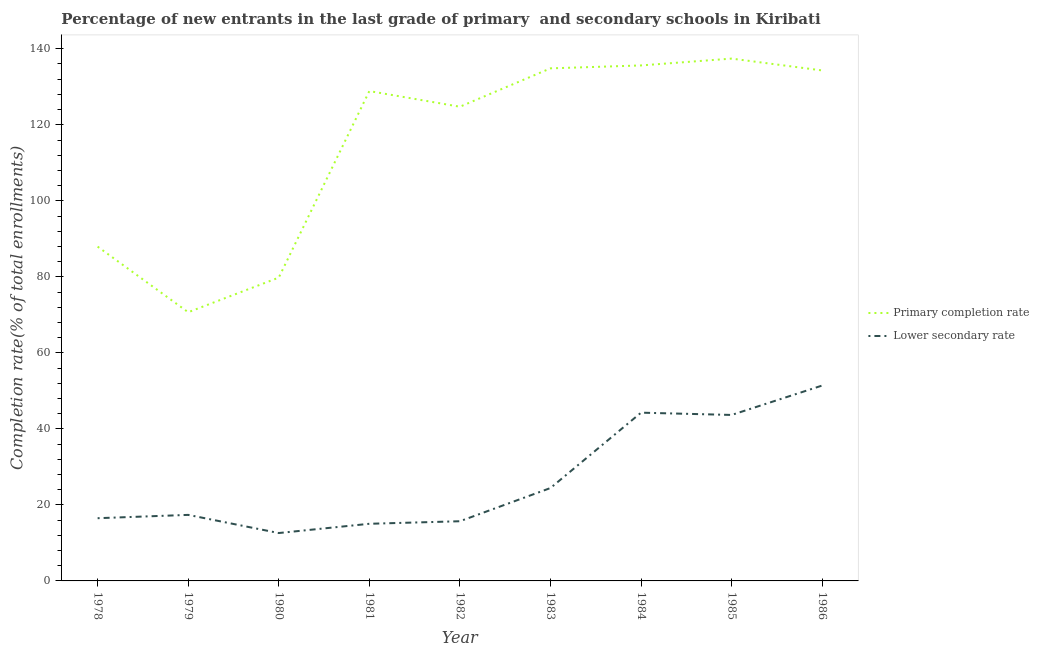How many different coloured lines are there?
Your answer should be very brief. 2. What is the completion rate in primary schools in 1983?
Ensure brevity in your answer.  134.85. Across all years, what is the maximum completion rate in primary schools?
Provide a short and direct response. 137.42. Across all years, what is the minimum completion rate in primary schools?
Your answer should be very brief. 70.69. In which year was the completion rate in primary schools minimum?
Ensure brevity in your answer.  1979. What is the total completion rate in primary schools in the graph?
Offer a terse response. 1034.25. What is the difference between the completion rate in secondary schools in 1978 and that in 1985?
Your answer should be compact. -27.17. What is the difference between the completion rate in secondary schools in 1980 and the completion rate in primary schools in 1985?
Make the answer very short. -124.82. What is the average completion rate in primary schools per year?
Keep it short and to the point. 114.92. In the year 1986, what is the difference between the completion rate in primary schools and completion rate in secondary schools?
Provide a short and direct response. 82.9. What is the ratio of the completion rate in secondary schools in 1979 to that in 1985?
Keep it short and to the point. 0.4. Is the difference between the completion rate in secondary schools in 1981 and 1984 greater than the difference between the completion rate in primary schools in 1981 and 1984?
Your response must be concise. No. What is the difference between the highest and the second highest completion rate in primary schools?
Keep it short and to the point. 1.8. What is the difference between the highest and the lowest completion rate in secondary schools?
Ensure brevity in your answer.  38.8. In how many years, is the completion rate in primary schools greater than the average completion rate in primary schools taken over all years?
Your response must be concise. 6. Is the sum of the completion rate in primary schools in 1978 and 1986 greater than the maximum completion rate in secondary schools across all years?
Your answer should be very brief. Yes. Is the completion rate in primary schools strictly less than the completion rate in secondary schools over the years?
Offer a very short reply. No. How many lines are there?
Give a very brief answer. 2. How many years are there in the graph?
Make the answer very short. 9. Does the graph contain any zero values?
Your response must be concise. No. What is the title of the graph?
Keep it short and to the point. Percentage of new entrants in the last grade of primary  and secondary schools in Kiribati. Does "Largest city" appear as one of the legend labels in the graph?
Keep it short and to the point. No. What is the label or title of the Y-axis?
Your answer should be very brief. Completion rate(% of total enrollments). What is the Completion rate(% of total enrollments) of Primary completion rate in 1978?
Ensure brevity in your answer.  87.95. What is the Completion rate(% of total enrollments) of Lower secondary rate in 1978?
Provide a succinct answer. 16.5. What is the Completion rate(% of total enrollments) of Primary completion rate in 1979?
Offer a very short reply. 70.69. What is the Completion rate(% of total enrollments) of Lower secondary rate in 1979?
Keep it short and to the point. 17.37. What is the Completion rate(% of total enrollments) of Primary completion rate in 1980?
Give a very brief answer. 79.8. What is the Completion rate(% of total enrollments) of Lower secondary rate in 1980?
Your answer should be very brief. 12.6. What is the Completion rate(% of total enrollments) in Primary completion rate in 1981?
Your answer should be very brief. 128.87. What is the Completion rate(% of total enrollments) of Lower secondary rate in 1981?
Give a very brief answer. 15.03. What is the Completion rate(% of total enrollments) in Primary completion rate in 1982?
Provide a succinct answer. 124.75. What is the Completion rate(% of total enrollments) in Lower secondary rate in 1982?
Make the answer very short. 15.7. What is the Completion rate(% of total enrollments) in Primary completion rate in 1983?
Offer a terse response. 134.85. What is the Completion rate(% of total enrollments) of Lower secondary rate in 1983?
Offer a terse response. 24.44. What is the Completion rate(% of total enrollments) in Primary completion rate in 1984?
Your answer should be compact. 135.62. What is the Completion rate(% of total enrollments) in Lower secondary rate in 1984?
Offer a very short reply. 44.26. What is the Completion rate(% of total enrollments) of Primary completion rate in 1985?
Offer a very short reply. 137.42. What is the Completion rate(% of total enrollments) in Lower secondary rate in 1985?
Provide a succinct answer. 43.67. What is the Completion rate(% of total enrollments) of Primary completion rate in 1986?
Give a very brief answer. 134.3. What is the Completion rate(% of total enrollments) of Lower secondary rate in 1986?
Your response must be concise. 51.4. Across all years, what is the maximum Completion rate(% of total enrollments) of Primary completion rate?
Your answer should be very brief. 137.42. Across all years, what is the maximum Completion rate(% of total enrollments) in Lower secondary rate?
Offer a very short reply. 51.4. Across all years, what is the minimum Completion rate(% of total enrollments) in Primary completion rate?
Keep it short and to the point. 70.69. Across all years, what is the minimum Completion rate(% of total enrollments) in Lower secondary rate?
Provide a succinct answer. 12.6. What is the total Completion rate(% of total enrollments) in Primary completion rate in the graph?
Your answer should be very brief. 1034.25. What is the total Completion rate(% of total enrollments) of Lower secondary rate in the graph?
Provide a succinct answer. 240.98. What is the difference between the Completion rate(% of total enrollments) in Primary completion rate in 1978 and that in 1979?
Keep it short and to the point. 17.26. What is the difference between the Completion rate(% of total enrollments) in Lower secondary rate in 1978 and that in 1979?
Offer a very short reply. -0.87. What is the difference between the Completion rate(% of total enrollments) of Primary completion rate in 1978 and that in 1980?
Offer a terse response. 8.15. What is the difference between the Completion rate(% of total enrollments) of Lower secondary rate in 1978 and that in 1980?
Keep it short and to the point. 3.9. What is the difference between the Completion rate(% of total enrollments) in Primary completion rate in 1978 and that in 1981?
Your answer should be compact. -40.92. What is the difference between the Completion rate(% of total enrollments) of Lower secondary rate in 1978 and that in 1981?
Ensure brevity in your answer.  1.47. What is the difference between the Completion rate(% of total enrollments) in Primary completion rate in 1978 and that in 1982?
Offer a very short reply. -36.81. What is the difference between the Completion rate(% of total enrollments) of Lower secondary rate in 1978 and that in 1982?
Ensure brevity in your answer.  0.8. What is the difference between the Completion rate(% of total enrollments) in Primary completion rate in 1978 and that in 1983?
Your answer should be compact. -46.9. What is the difference between the Completion rate(% of total enrollments) in Lower secondary rate in 1978 and that in 1983?
Provide a succinct answer. -7.94. What is the difference between the Completion rate(% of total enrollments) in Primary completion rate in 1978 and that in 1984?
Provide a succinct answer. -47.67. What is the difference between the Completion rate(% of total enrollments) of Lower secondary rate in 1978 and that in 1984?
Your answer should be very brief. -27.76. What is the difference between the Completion rate(% of total enrollments) in Primary completion rate in 1978 and that in 1985?
Make the answer very short. -49.47. What is the difference between the Completion rate(% of total enrollments) of Lower secondary rate in 1978 and that in 1985?
Give a very brief answer. -27.17. What is the difference between the Completion rate(% of total enrollments) of Primary completion rate in 1978 and that in 1986?
Your response must be concise. -46.35. What is the difference between the Completion rate(% of total enrollments) in Lower secondary rate in 1978 and that in 1986?
Your answer should be very brief. -34.9. What is the difference between the Completion rate(% of total enrollments) in Primary completion rate in 1979 and that in 1980?
Provide a short and direct response. -9.11. What is the difference between the Completion rate(% of total enrollments) in Lower secondary rate in 1979 and that in 1980?
Provide a short and direct response. 4.78. What is the difference between the Completion rate(% of total enrollments) in Primary completion rate in 1979 and that in 1981?
Offer a terse response. -58.18. What is the difference between the Completion rate(% of total enrollments) of Lower secondary rate in 1979 and that in 1981?
Make the answer very short. 2.34. What is the difference between the Completion rate(% of total enrollments) of Primary completion rate in 1979 and that in 1982?
Offer a very short reply. -54.06. What is the difference between the Completion rate(% of total enrollments) in Lower secondary rate in 1979 and that in 1982?
Make the answer very short. 1.67. What is the difference between the Completion rate(% of total enrollments) in Primary completion rate in 1979 and that in 1983?
Provide a short and direct response. -64.16. What is the difference between the Completion rate(% of total enrollments) in Lower secondary rate in 1979 and that in 1983?
Provide a short and direct response. -7.07. What is the difference between the Completion rate(% of total enrollments) in Primary completion rate in 1979 and that in 1984?
Make the answer very short. -64.93. What is the difference between the Completion rate(% of total enrollments) in Lower secondary rate in 1979 and that in 1984?
Your response must be concise. -26.89. What is the difference between the Completion rate(% of total enrollments) of Primary completion rate in 1979 and that in 1985?
Offer a very short reply. -66.73. What is the difference between the Completion rate(% of total enrollments) in Lower secondary rate in 1979 and that in 1985?
Make the answer very short. -26.29. What is the difference between the Completion rate(% of total enrollments) in Primary completion rate in 1979 and that in 1986?
Provide a short and direct response. -63.61. What is the difference between the Completion rate(% of total enrollments) of Lower secondary rate in 1979 and that in 1986?
Make the answer very short. -34.03. What is the difference between the Completion rate(% of total enrollments) in Primary completion rate in 1980 and that in 1981?
Your response must be concise. -49.07. What is the difference between the Completion rate(% of total enrollments) in Lower secondary rate in 1980 and that in 1981?
Your answer should be very brief. -2.43. What is the difference between the Completion rate(% of total enrollments) of Primary completion rate in 1980 and that in 1982?
Offer a very short reply. -44.96. What is the difference between the Completion rate(% of total enrollments) in Lower secondary rate in 1980 and that in 1982?
Ensure brevity in your answer.  -3.11. What is the difference between the Completion rate(% of total enrollments) in Primary completion rate in 1980 and that in 1983?
Provide a short and direct response. -55.05. What is the difference between the Completion rate(% of total enrollments) of Lower secondary rate in 1980 and that in 1983?
Your answer should be very brief. -11.84. What is the difference between the Completion rate(% of total enrollments) of Primary completion rate in 1980 and that in 1984?
Ensure brevity in your answer.  -55.82. What is the difference between the Completion rate(% of total enrollments) in Lower secondary rate in 1980 and that in 1984?
Make the answer very short. -31.67. What is the difference between the Completion rate(% of total enrollments) of Primary completion rate in 1980 and that in 1985?
Your response must be concise. -57.62. What is the difference between the Completion rate(% of total enrollments) in Lower secondary rate in 1980 and that in 1985?
Give a very brief answer. -31.07. What is the difference between the Completion rate(% of total enrollments) of Primary completion rate in 1980 and that in 1986?
Provide a short and direct response. -54.5. What is the difference between the Completion rate(% of total enrollments) of Lower secondary rate in 1980 and that in 1986?
Your answer should be very brief. -38.8. What is the difference between the Completion rate(% of total enrollments) of Primary completion rate in 1981 and that in 1982?
Offer a terse response. 4.12. What is the difference between the Completion rate(% of total enrollments) in Lower secondary rate in 1981 and that in 1982?
Offer a terse response. -0.67. What is the difference between the Completion rate(% of total enrollments) in Primary completion rate in 1981 and that in 1983?
Make the answer very short. -5.98. What is the difference between the Completion rate(% of total enrollments) of Lower secondary rate in 1981 and that in 1983?
Your answer should be compact. -9.41. What is the difference between the Completion rate(% of total enrollments) of Primary completion rate in 1981 and that in 1984?
Offer a terse response. -6.75. What is the difference between the Completion rate(% of total enrollments) in Lower secondary rate in 1981 and that in 1984?
Make the answer very short. -29.23. What is the difference between the Completion rate(% of total enrollments) in Primary completion rate in 1981 and that in 1985?
Make the answer very short. -8.55. What is the difference between the Completion rate(% of total enrollments) in Lower secondary rate in 1981 and that in 1985?
Provide a succinct answer. -28.63. What is the difference between the Completion rate(% of total enrollments) of Primary completion rate in 1981 and that in 1986?
Your response must be concise. -5.43. What is the difference between the Completion rate(% of total enrollments) of Lower secondary rate in 1981 and that in 1986?
Offer a very short reply. -36.37. What is the difference between the Completion rate(% of total enrollments) in Primary completion rate in 1982 and that in 1983?
Provide a short and direct response. -10.1. What is the difference between the Completion rate(% of total enrollments) in Lower secondary rate in 1982 and that in 1983?
Your answer should be very brief. -8.74. What is the difference between the Completion rate(% of total enrollments) in Primary completion rate in 1982 and that in 1984?
Ensure brevity in your answer.  -10.86. What is the difference between the Completion rate(% of total enrollments) of Lower secondary rate in 1982 and that in 1984?
Your answer should be compact. -28.56. What is the difference between the Completion rate(% of total enrollments) of Primary completion rate in 1982 and that in 1985?
Keep it short and to the point. -12.66. What is the difference between the Completion rate(% of total enrollments) of Lower secondary rate in 1982 and that in 1985?
Offer a terse response. -27.96. What is the difference between the Completion rate(% of total enrollments) in Primary completion rate in 1982 and that in 1986?
Offer a very short reply. -9.55. What is the difference between the Completion rate(% of total enrollments) of Lower secondary rate in 1982 and that in 1986?
Your answer should be very brief. -35.7. What is the difference between the Completion rate(% of total enrollments) in Primary completion rate in 1983 and that in 1984?
Offer a very short reply. -0.77. What is the difference between the Completion rate(% of total enrollments) of Lower secondary rate in 1983 and that in 1984?
Provide a succinct answer. -19.83. What is the difference between the Completion rate(% of total enrollments) of Primary completion rate in 1983 and that in 1985?
Your response must be concise. -2.57. What is the difference between the Completion rate(% of total enrollments) of Lower secondary rate in 1983 and that in 1985?
Make the answer very short. -19.23. What is the difference between the Completion rate(% of total enrollments) in Primary completion rate in 1983 and that in 1986?
Your answer should be compact. 0.55. What is the difference between the Completion rate(% of total enrollments) of Lower secondary rate in 1983 and that in 1986?
Your answer should be compact. -26.96. What is the difference between the Completion rate(% of total enrollments) in Primary completion rate in 1984 and that in 1985?
Give a very brief answer. -1.8. What is the difference between the Completion rate(% of total enrollments) in Lower secondary rate in 1984 and that in 1985?
Your answer should be very brief. 0.6. What is the difference between the Completion rate(% of total enrollments) of Primary completion rate in 1984 and that in 1986?
Ensure brevity in your answer.  1.32. What is the difference between the Completion rate(% of total enrollments) in Lower secondary rate in 1984 and that in 1986?
Provide a short and direct response. -7.14. What is the difference between the Completion rate(% of total enrollments) of Primary completion rate in 1985 and that in 1986?
Make the answer very short. 3.12. What is the difference between the Completion rate(% of total enrollments) of Lower secondary rate in 1985 and that in 1986?
Provide a short and direct response. -7.74. What is the difference between the Completion rate(% of total enrollments) of Primary completion rate in 1978 and the Completion rate(% of total enrollments) of Lower secondary rate in 1979?
Offer a very short reply. 70.58. What is the difference between the Completion rate(% of total enrollments) of Primary completion rate in 1978 and the Completion rate(% of total enrollments) of Lower secondary rate in 1980?
Your answer should be compact. 75.35. What is the difference between the Completion rate(% of total enrollments) in Primary completion rate in 1978 and the Completion rate(% of total enrollments) in Lower secondary rate in 1981?
Ensure brevity in your answer.  72.92. What is the difference between the Completion rate(% of total enrollments) in Primary completion rate in 1978 and the Completion rate(% of total enrollments) in Lower secondary rate in 1982?
Your answer should be very brief. 72.25. What is the difference between the Completion rate(% of total enrollments) in Primary completion rate in 1978 and the Completion rate(% of total enrollments) in Lower secondary rate in 1983?
Keep it short and to the point. 63.51. What is the difference between the Completion rate(% of total enrollments) in Primary completion rate in 1978 and the Completion rate(% of total enrollments) in Lower secondary rate in 1984?
Give a very brief answer. 43.68. What is the difference between the Completion rate(% of total enrollments) in Primary completion rate in 1978 and the Completion rate(% of total enrollments) in Lower secondary rate in 1985?
Your response must be concise. 44.28. What is the difference between the Completion rate(% of total enrollments) of Primary completion rate in 1978 and the Completion rate(% of total enrollments) of Lower secondary rate in 1986?
Your answer should be very brief. 36.55. What is the difference between the Completion rate(% of total enrollments) in Primary completion rate in 1979 and the Completion rate(% of total enrollments) in Lower secondary rate in 1980?
Offer a very short reply. 58.09. What is the difference between the Completion rate(% of total enrollments) of Primary completion rate in 1979 and the Completion rate(% of total enrollments) of Lower secondary rate in 1981?
Provide a succinct answer. 55.66. What is the difference between the Completion rate(% of total enrollments) in Primary completion rate in 1979 and the Completion rate(% of total enrollments) in Lower secondary rate in 1982?
Make the answer very short. 54.99. What is the difference between the Completion rate(% of total enrollments) of Primary completion rate in 1979 and the Completion rate(% of total enrollments) of Lower secondary rate in 1983?
Give a very brief answer. 46.25. What is the difference between the Completion rate(% of total enrollments) of Primary completion rate in 1979 and the Completion rate(% of total enrollments) of Lower secondary rate in 1984?
Provide a succinct answer. 26.43. What is the difference between the Completion rate(% of total enrollments) of Primary completion rate in 1979 and the Completion rate(% of total enrollments) of Lower secondary rate in 1985?
Provide a short and direct response. 27.03. What is the difference between the Completion rate(% of total enrollments) in Primary completion rate in 1979 and the Completion rate(% of total enrollments) in Lower secondary rate in 1986?
Ensure brevity in your answer.  19.29. What is the difference between the Completion rate(% of total enrollments) of Primary completion rate in 1980 and the Completion rate(% of total enrollments) of Lower secondary rate in 1981?
Ensure brevity in your answer.  64.77. What is the difference between the Completion rate(% of total enrollments) in Primary completion rate in 1980 and the Completion rate(% of total enrollments) in Lower secondary rate in 1982?
Ensure brevity in your answer.  64.1. What is the difference between the Completion rate(% of total enrollments) of Primary completion rate in 1980 and the Completion rate(% of total enrollments) of Lower secondary rate in 1983?
Provide a succinct answer. 55.36. What is the difference between the Completion rate(% of total enrollments) in Primary completion rate in 1980 and the Completion rate(% of total enrollments) in Lower secondary rate in 1984?
Provide a succinct answer. 35.53. What is the difference between the Completion rate(% of total enrollments) in Primary completion rate in 1980 and the Completion rate(% of total enrollments) in Lower secondary rate in 1985?
Offer a terse response. 36.13. What is the difference between the Completion rate(% of total enrollments) of Primary completion rate in 1980 and the Completion rate(% of total enrollments) of Lower secondary rate in 1986?
Your answer should be very brief. 28.4. What is the difference between the Completion rate(% of total enrollments) in Primary completion rate in 1981 and the Completion rate(% of total enrollments) in Lower secondary rate in 1982?
Provide a short and direct response. 113.17. What is the difference between the Completion rate(% of total enrollments) in Primary completion rate in 1981 and the Completion rate(% of total enrollments) in Lower secondary rate in 1983?
Make the answer very short. 104.43. What is the difference between the Completion rate(% of total enrollments) in Primary completion rate in 1981 and the Completion rate(% of total enrollments) in Lower secondary rate in 1984?
Your answer should be very brief. 84.61. What is the difference between the Completion rate(% of total enrollments) of Primary completion rate in 1981 and the Completion rate(% of total enrollments) of Lower secondary rate in 1985?
Ensure brevity in your answer.  85.21. What is the difference between the Completion rate(% of total enrollments) in Primary completion rate in 1981 and the Completion rate(% of total enrollments) in Lower secondary rate in 1986?
Give a very brief answer. 77.47. What is the difference between the Completion rate(% of total enrollments) of Primary completion rate in 1982 and the Completion rate(% of total enrollments) of Lower secondary rate in 1983?
Provide a short and direct response. 100.31. What is the difference between the Completion rate(% of total enrollments) of Primary completion rate in 1982 and the Completion rate(% of total enrollments) of Lower secondary rate in 1984?
Ensure brevity in your answer.  80.49. What is the difference between the Completion rate(% of total enrollments) in Primary completion rate in 1982 and the Completion rate(% of total enrollments) in Lower secondary rate in 1985?
Provide a short and direct response. 81.09. What is the difference between the Completion rate(% of total enrollments) of Primary completion rate in 1982 and the Completion rate(% of total enrollments) of Lower secondary rate in 1986?
Your response must be concise. 73.35. What is the difference between the Completion rate(% of total enrollments) in Primary completion rate in 1983 and the Completion rate(% of total enrollments) in Lower secondary rate in 1984?
Your answer should be compact. 90.59. What is the difference between the Completion rate(% of total enrollments) of Primary completion rate in 1983 and the Completion rate(% of total enrollments) of Lower secondary rate in 1985?
Keep it short and to the point. 91.19. What is the difference between the Completion rate(% of total enrollments) of Primary completion rate in 1983 and the Completion rate(% of total enrollments) of Lower secondary rate in 1986?
Provide a succinct answer. 83.45. What is the difference between the Completion rate(% of total enrollments) in Primary completion rate in 1984 and the Completion rate(% of total enrollments) in Lower secondary rate in 1985?
Keep it short and to the point. 91.95. What is the difference between the Completion rate(% of total enrollments) in Primary completion rate in 1984 and the Completion rate(% of total enrollments) in Lower secondary rate in 1986?
Give a very brief answer. 84.22. What is the difference between the Completion rate(% of total enrollments) of Primary completion rate in 1985 and the Completion rate(% of total enrollments) of Lower secondary rate in 1986?
Ensure brevity in your answer.  86.01. What is the average Completion rate(% of total enrollments) in Primary completion rate per year?
Your answer should be very brief. 114.92. What is the average Completion rate(% of total enrollments) in Lower secondary rate per year?
Your response must be concise. 26.78. In the year 1978, what is the difference between the Completion rate(% of total enrollments) of Primary completion rate and Completion rate(% of total enrollments) of Lower secondary rate?
Your answer should be very brief. 71.45. In the year 1979, what is the difference between the Completion rate(% of total enrollments) in Primary completion rate and Completion rate(% of total enrollments) in Lower secondary rate?
Keep it short and to the point. 53.32. In the year 1980, what is the difference between the Completion rate(% of total enrollments) of Primary completion rate and Completion rate(% of total enrollments) of Lower secondary rate?
Give a very brief answer. 67.2. In the year 1981, what is the difference between the Completion rate(% of total enrollments) in Primary completion rate and Completion rate(% of total enrollments) in Lower secondary rate?
Your response must be concise. 113.84. In the year 1982, what is the difference between the Completion rate(% of total enrollments) in Primary completion rate and Completion rate(% of total enrollments) in Lower secondary rate?
Provide a succinct answer. 109.05. In the year 1983, what is the difference between the Completion rate(% of total enrollments) in Primary completion rate and Completion rate(% of total enrollments) in Lower secondary rate?
Keep it short and to the point. 110.41. In the year 1984, what is the difference between the Completion rate(% of total enrollments) of Primary completion rate and Completion rate(% of total enrollments) of Lower secondary rate?
Offer a terse response. 91.35. In the year 1985, what is the difference between the Completion rate(% of total enrollments) in Primary completion rate and Completion rate(% of total enrollments) in Lower secondary rate?
Make the answer very short. 93.75. In the year 1986, what is the difference between the Completion rate(% of total enrollments) of Primary completion rate and Completion rate(% of total enrollments) of Lower secondary rate?
Keep it short and to the point. 82.9. What is the ratio of the Completion rate(% of total enrollments) of Primary completion rate in 1978 to that in 1979?
Your answer should be compact. 1.24. What is the ratio of the Completion rate(% of total enrollments) in Lower secondary rate in 1978 to that in 1979?
Keep it short and to the point. 0.95. What is the ratio of the Completion rate(% of total enrollments) in Primary completion rate in 1978 to that in 1980?
Keep it short and to the point. 1.1. What is the ratio of the Completion rate(% of total enrollments) in Lower secondary rate in 1978 to that in 1980?
Provide a succinct answer. 1.31. What is the ratio of the Completion rate(% of total enrollments) of Primary completion rate in 1978 to that in 1981?
Ensure brevity in your answer.  0.68. What is the ratio of the Completion rate(% of total enrollments) of Lower secondary rate in 1978 to that in 1981?
Your answer should be compact. 1.1. What is the ratio of the Completion rate(% of total enrollments) in Primary completion rate in 1978 to that in 1982?
Make the answer very short. 0.7. What is the ratio of the Completion rate(% of total enrollments) of Lower secondary rate in 1978 to that in 1982?
Your response must be concise. 1.05. What is the ratio of the Completion rate(% of total enrollments) in Primary completion rate in 1978 to that in 1983?
Provide a short and direct response. 0.65. What is the ratio of the Completion rate(% of total enrollments) of Lower secondary rate in 1978 to that in 1983?
Provide a succinct answer. 0.68. What is the ratio of the Completion rate(% of total enrollments) of Primary completion rate in 1978 to that in 1984?
Make the answer very short. 0.65. What is the ratio of the Completion rate(% of total enrollments) of Lower secondary rate in 1978 to that in 1984?
Your response must be concise. 0.37. What is the ratio of the Completion rate(% of total enrollments) of Primary completion rate in 1978 to that in 1985?
Provide a short and direct response. 0.64. What is the ratio of the Completion rate(% of total enrollments) of Lower secondary rate in 1978 to that in 1985?
Offer a terse response. 0.38. What is the ratio of the Completion rate(% of total enrollments) in Primary completion rate in 1978 to that in 1986?
Offer a very short reply. 0.65. What is the ratio of the Completion rate(% of total enrollments) of Lower secondary rate in 1978 to that in 1986?
Your response must be concise. 0.32. What is the ratio of the Completion rate(% of total enrollments) of Primary completion rate in 1979 to that in 1980?
Offer a very short reply. 0.89. What is the ratio of the Completion rate(% of total enrollments) of Lower secondary rate in 1979 to that in 1980?
Your answer should be compact. 1.38. What is the ratio of the Completion rate(% of total enrollments) in Primary completion rate in 1979 to that in 1981?
Make the answer very short. 0.55. What is the ratio of the Completion rate(% of total enrollments) of Lower secondary rate in 1979 to that in 1981?
Offer a terse response. 1.16. What is the ratio of the Completion rate(% of total enrollments) of Primary completion rate in 1979 to that in 1982?
Provide a succinct answer. 0.57. What is the ratio of the Completion rate(% of total enrollments) in Lower secondary rate in 1979 to that in 1982?
Keep it short and to the point. 1.11. What is the ratio of the Completion rate(% of total enrollments) of Primary completion rate in 1979 to that in 1983?
Keep it short and to the point. 0.52. What is the ratio of the Completion rate(% of total enrollments) of Lower secondary rate in 1979 to that in 1983?
Make the answer very short. 0.71. What is the ratio of the Completion rate(% of total enrollments) of Primary completion rate in 1979 to that in 1984?
Your response must be concise. 0.52. What is the ratio of the Completion rate(% of total enrollments) of Lower secondary rate in 1979 to that in 1984?
Make the answer very short. 0.39. What is the ratio of the Completion rate(% of total enrollments) of Primary completion rate in 1979 to that in 1985?
Your response must be concise. 0.51. What is the ratio of the Completion rate(% of total enrollments) in Lower secondary rate in 1979 to that in 1985?
Provide a short and direct response. 0.4. What is the ratio of the Completion rate(% of total enrollments) of Primary completion rate in 1979 to that in 1986?
Provide a succinct answer. 0.53. What is the ratio of the Completion rate(% of total enrollments) of Lower secondary rate in 1979 to that in 1986?
Your answer should be very brief. 0.34. What is the ratio of the Completion rate(% of total enrollments) in Primary completion rate in 1980 to that in 1981?
Make the answer very short. 0.62. What is the ratio of the Completion rate(% of total enrollments) of Lower secondary rate in 1980 to that in 1981?
Provide a succinct answer. 0.84. What is the ratio of the Completion rate(% of total enrollments) of Primary completion rate in 1980 to that in 1982?
Offer a terse response. 0.64. What is the ratio of the Completion rate(% of total enrollments) of Lower secondary rate in 1980 to that in 1982?
Offer a terse response. 0.8. What is the ratio of the Completion rate(% of total enrollments) of Primary completion rate in 1980 to that in 1983?
Provide a succinct answer. 0.59. What is the ratio of the Completion rate(% of total enrollments) of Lower secondary rate in 1980 to that in 1983?
Make the answer very short. 0.52. What is the ratio of the Completion rate(% of total enrollments) of Primary completion rate in 1980 to that in 1984?
Provide a succinct answer. 0.59. What is the ratio of the Completion rate(% of total enrollments) in Lower secondary rate in 1980 to that in 1984?
Your response must be concise. 0.28. What is the ratio of the Completion rate(% of total enrollments) of Primary completion rate in 1980 to that in 1985?
Provide a succinct answer. 0.58. What is the ratio of the Completion rate(% of total enrollments) of Lower secondary rate in 1980 to that in 1985?
Your answer should be very brief. 0.29. What is the ratio of the Completion rate(% of total enrollments) in Primary completion rate in 1980 to that in 1986?
Make the answer very short. 0.59. What is the ratio of the Completion rate(% of total enrollments) in Lower secondary rate in 1980 to that in 1986?
Ensure brevity in your answer.  0.25. What is the ratio of the Completion rate(% of total enrollments) of Primary completion rate in 1981 to that in 1982?
Offer a very short reply. 1.03. What is the ratio of the Completion rate(% of total enrollments) of Lower secondary rate in 1981 to that in 1982?
Make the answer very short. 0.96. What is the ratio of the Completion rate(% of total enrollments) of Primary completion rate in 1981 to that in 1983?
Your response must be concise. 0.96. What is the ratio of the Completion rate(% of total enrollments) in Lower secondary rate in 1981 to that in 1983?
Offer a terse response. 0.62. What is the ratio of the Completion rate(% of total enrollments) of Primary completion rate in 1981 to that in 1984?
Offer a terse response. 0.95. What is the ratio of the Completion rate(% of total enrollments) in Lower secondary rate in 1981 to that in 1984?
Give a very brief answer. 0.34. What is the ratio of the Completion rate(% of total enrollments) in Primary completion rate in 1981 to that in 1985?
Your answer should be compact. 0.94. What is the ratio of the Completion rate(% of total enrollments) of Lower secondary rate in 1981 to that in 1985?
Your answer should be very brief. 0.34. What is the ratio of the Completion rate(% of total enrollments) in Primary completion rate in 1981 to that in 1986?
Your answer should be very brief. 0.96. What is the ratio of the Completion rate(% of total enrollments) of Lower secondary rate in 1981 to that in 1986?
Your answer should be very brief. 0.29. What is the ratio of the Completion rate(% of total enrollments) of Primary completion rate in 1982 to that in 1983?
Give a very brief answer. 0.93. What is the ratio of the Completion rate(% of total enrollments) in Lower secondary rate in 1982 to that in 1983?
Give a very brief answer. 0.64. What is the ratio of the Completion rate(% of total enrollments) of Primary completion rate in 1982 to that in 1984?
Make the answer very short. 0.92. What is the ratio of the Completion rate(% of total enrollments) of Lower secondary rate in 1982 to that in 1984?
Provide a succinct answer. 0.35. What is the ratio of the Completion rate(% of total enrollments) of Primary completion rate in 1982 to that in 1985?
Offer a very short reply. 0.91. What is the ratio of the Completion rate(% of total enrollments) in Lower secondary rate in 1982 to that in 1985?
Your answer should be very brief. 0.36. What is the ratio of the Completion rate(% of total enrollments) in Primary completion rate in 1982 to that in 1986?
Your answer should be very brief. 0.93. What is the ratio of the Completion rate(% of total enrollments) of Lower secondary rate in 1982 to that in 1986?
Provide a succinct answer. 0.31. What is the ratio of the Completion rate(% of total enrollments) in Primary completion rate in 1983 to that in 1984?
Make the answer very short. 0.99. What is the ratio of the Completion rate(% of total enrollments) of Lower secondary rate in 1983 to that in 1984?
Your answer should be compact. 0.55. What is the ratio of the Completion rate(% of total enrollments) of Primary completion rate in 1983 to that in 1985?
Your answer should be very brief. 0.98. What is the ratio of the Completion rate(% of total enrollments) of Lower secondary rate in 1983 to that in 1985?
Ensure brevity in your answer.  0.56. What is the ratio of the Completion rate(% of total enrollments) in Primary completion rate in 1983 to that in 1986?
Your response must be concise. 1. What is the ratio of the Completion rate(% of total enrollments) of Lower secondary rate in 1983 to that in 1986?
Your answer should be compact. 0.48. What is the ratio of the Completion rate(% of total enrollments) in Primary completion rate in 1984 to that in 1985?
Provide a short and direct response. 0.99. What is the ratio of the Completion rate(% of total enrollments) of Lower secondary rate in 1984 to that in 1985?
Your response must be concise. 1.01. What is the ratio of the Completion rate(% of total enrollments) of Primary completion rate in 1984 to that in 1986?
Provide a succinct answer. 1.01. What is the ratio of the Completion rate(% of total enrollments) of Lower secondary rate in 1984 to that in 1986?
Give a very brief answer. 0.86. What is the ratio of the Completion rate(% of total enrollments) of Primary completion rate in 1985 to that in 1986?
Your response must be concise. 1.02. What is the ratio of the Completion rate(% of total enrollments) in Lower secondary rate in 1985 to that in 1986?
Your answer should be very brief. 0.85. What is the difference between the highest and the second highest Completion rate(% of total enrollments) of Primary completion rate?
Provide a succinct answer. 1.8. What is the difference between the highest and the second highest Completion rate(% of total enrollments) of Lower secondary rate?
Provide a succinct answer. 7.14. What is the difference between the highest and the lowest Completion rate(% of total enrollments) in Primary completion rate?
Make the answer very short. 66.73. What is the difference between the highest and the lowest Completion rate(% of total enrollments) of Lower secondary rate?
Provide a succinct answer. 38.8. 